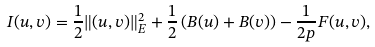<formula> <loc_0><loc_0><loc_500><loc_500>I ( u , v ) = \frac { 1 } { 2 } \| ( u , v ) \| _ { E } ^ { 2 } + \frac { 1 } { 2 } \left ( B ( u ) + B ( v ) \right ) - \frac { 1 } { 2 p } F ( u , v ) ,</formula> 